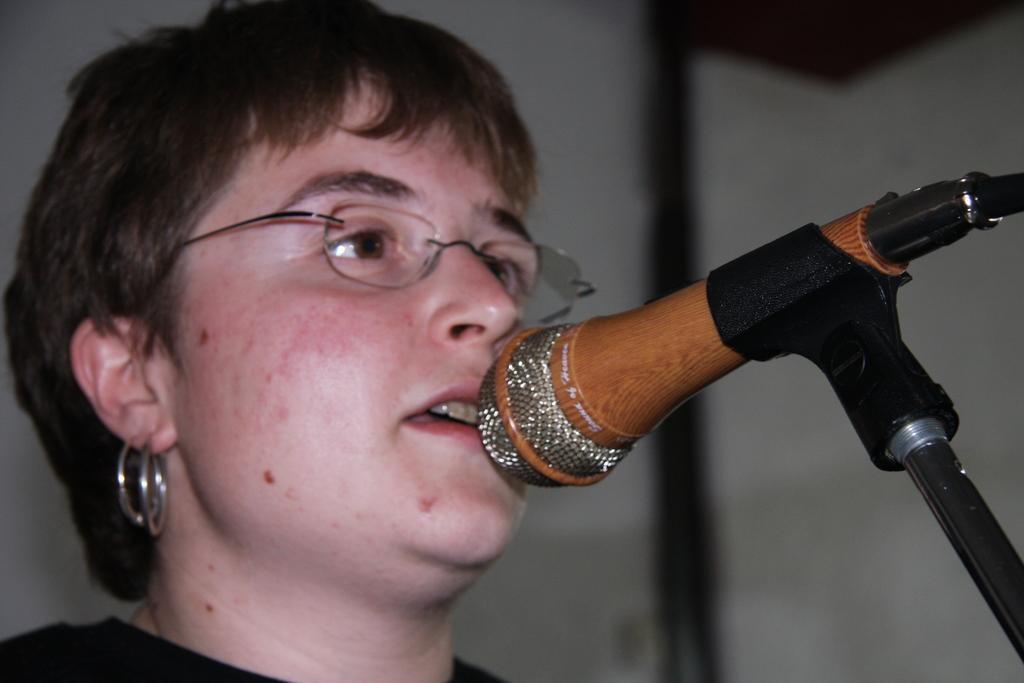Please provide a concise description of this image. On the left there is a person. On the right there is a mic. The background is blurred. 